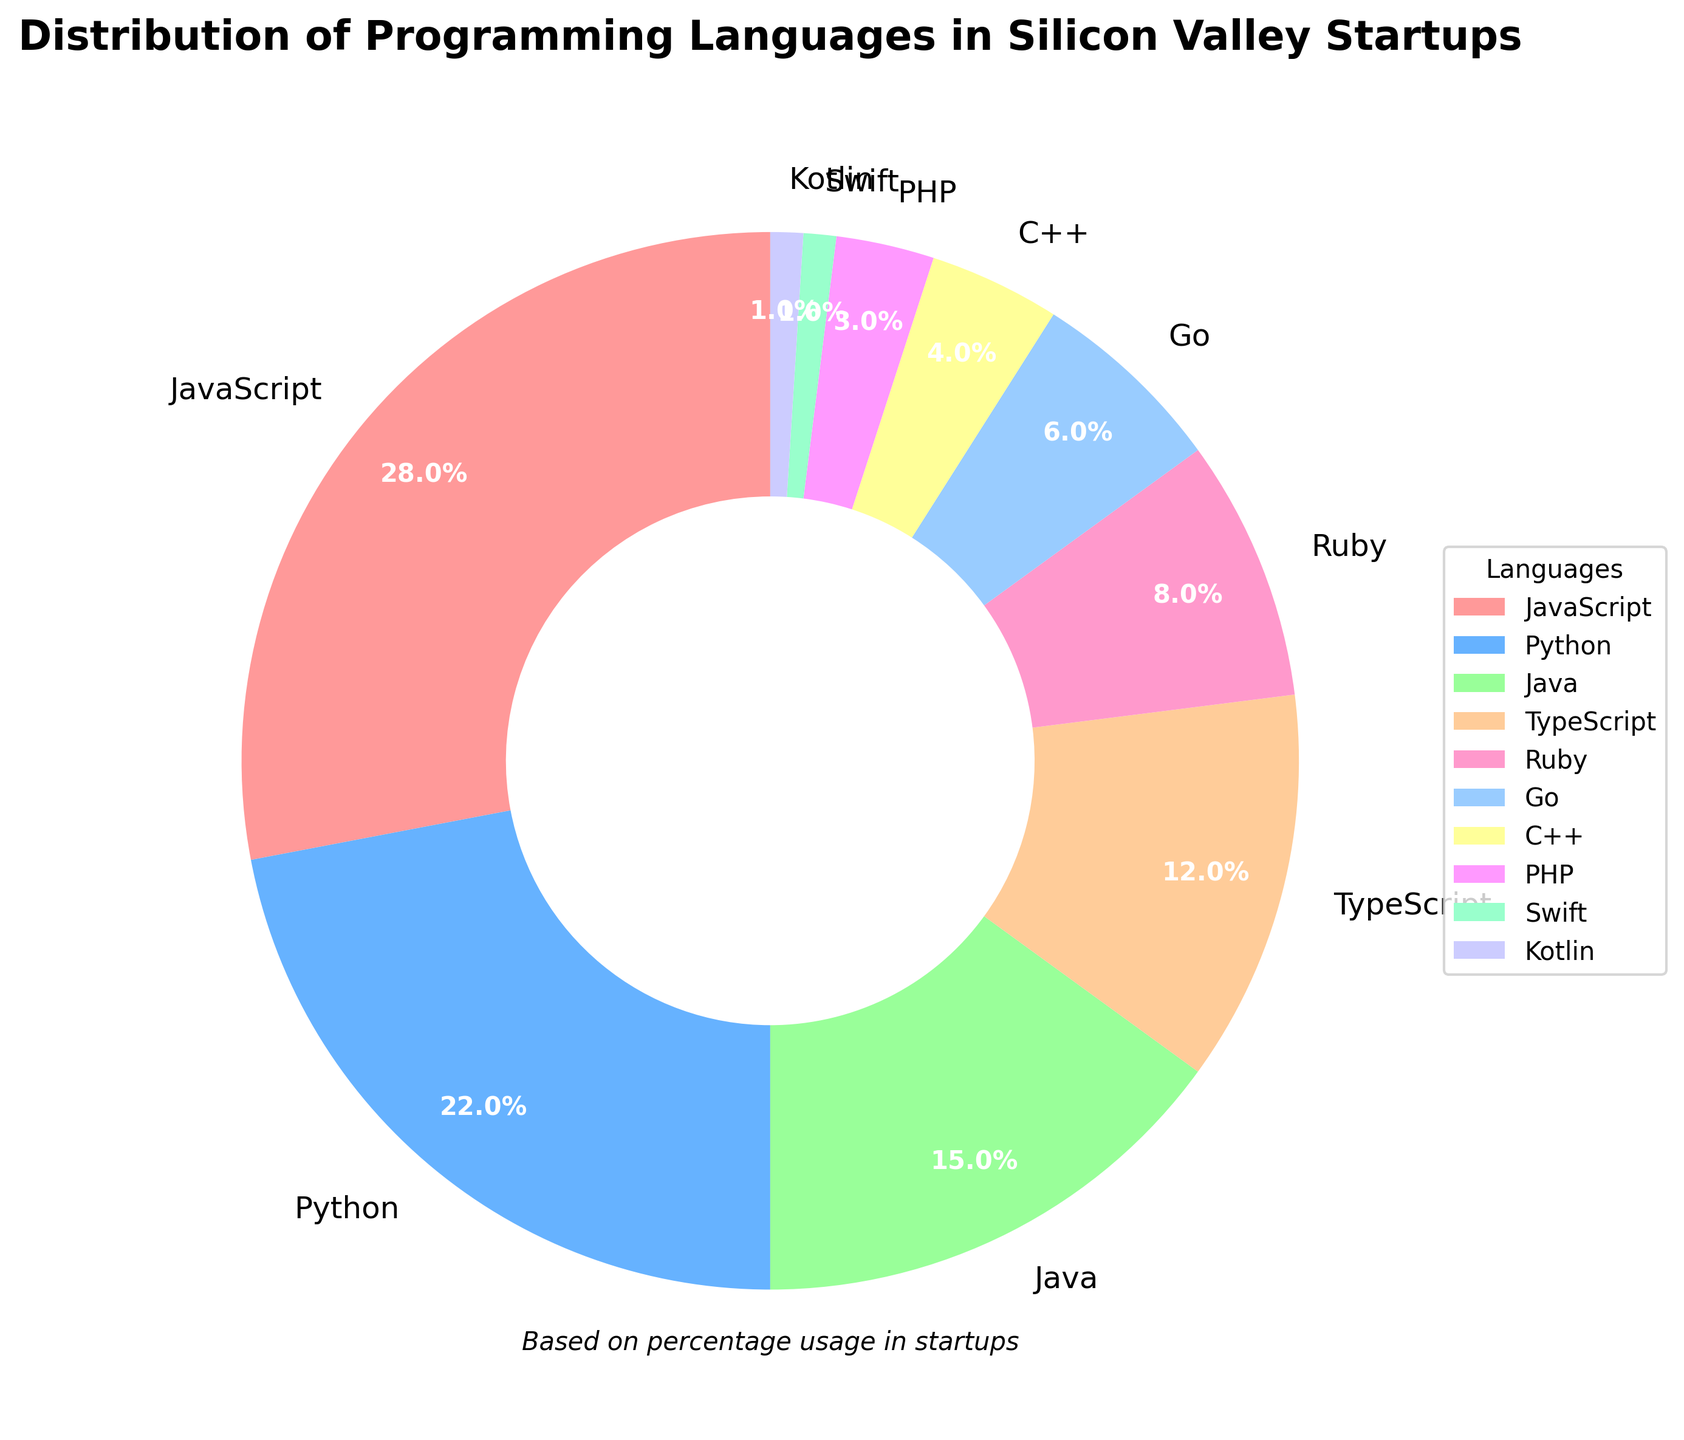Which programming language is used the most by Silicon Valley startups? The pie chart shows the segments labeled with percentages for each language. The largest segment belongs to JavaScript, which accounts for 28%.
Answer: JavaScript Which language has the smallest percentage of usage? By looking at the pie chart, the smallest segment is associated with Swift and Kotlin, each representing 1%.
Answer: Swift and Kotlin How much more is JavaScript used compared to Ruby? JavaScript usage is 28%, and Ruby usage is 8%. Subtracting Ruby’s percentage from JavaScript’s gives 28% - 8% = 20%.
Answer: 20% What are the combined percentages of Go and C++? According to the pie chart, Go is used 6% and C++ is used 4%. Adding these together gives 6% + 4% = 10%.
Answer: 10% Which languages are used by less than 5% of startups? From the chart, PHP (3%), Swift (1%), and Kotlin (1%) each have less than 5% usage.
Answer: PHP, Swift, Kotlin How does the usage of Python compare to TypeScript? The pie chart shows that Python is used 22% while TypeScript is used 12%. This means Python is used 10% more than TypeScript.
Answer: Python is used 10% more What is the sum of the usage percentages for Python, Ruby, and Go? According to the chart: Python (22%), Ruby (8%), and Go (6%). Adding these together: 22% + 8% + 6% = 36%.
Answer: 36% What percentage of startups use Java, TypeScript, and Ruby combined? The pie chart indicates Java (15%), TypeScript (12%), and Ruby (8%). Summing these values: 15% + 12% + 8% = 35%.
Answer: 35% Which segment is colored red in the pie chart? The first segment in the chart, representing JavaScript with 28%, is colored red.
Answer: JavaScript 